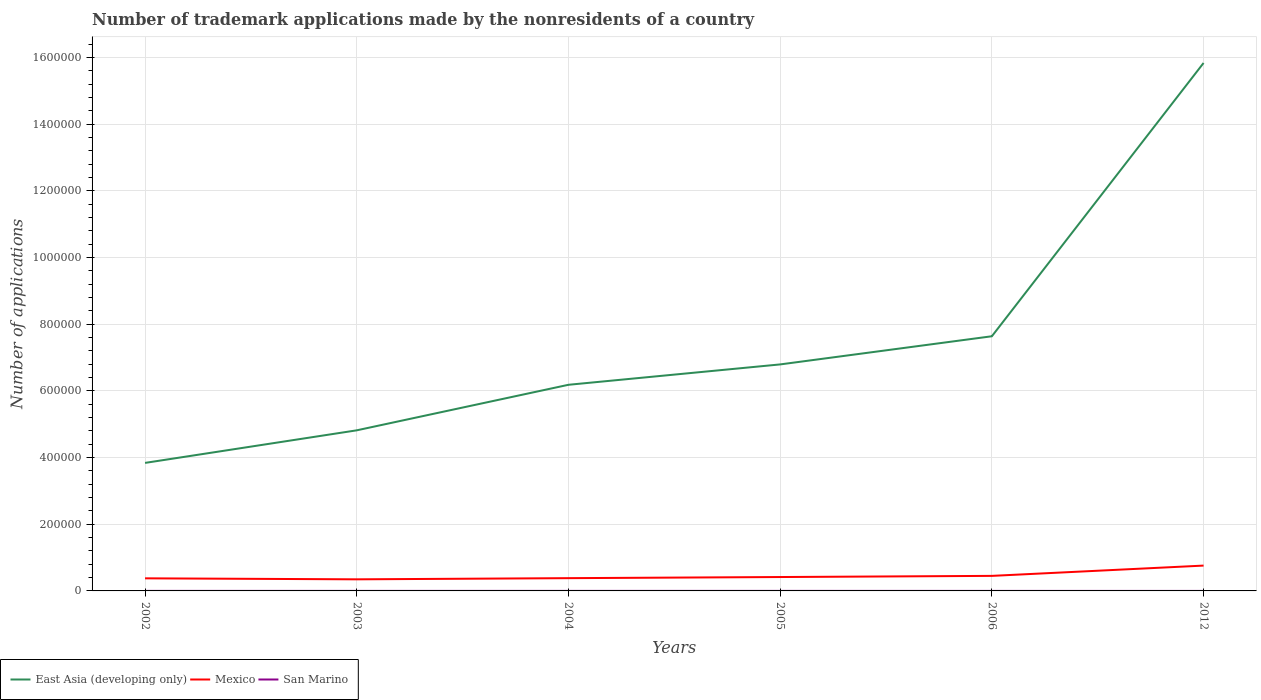How many different coloured lines are there?
Ensure brevity in your answer.  3. Does the line corresponding to East Asia (developing only) intersect with the line corresponding to Mexico?
Give a very brief answer. No. Is the number of lines equal to the number of legend labels?
Your answer should be compact. Yes. Across all years, what is the maximum number of trademark applications made by the nonresidents in Mexico?
Your response must be concise. 3.48e+04. What is the total number of trademark applications made by the nonresidents in Mexico in the graph?
Offer a very short reply. -550. What is the difference between the highest and the second highest number of trademark applications made by the nonresidents in East Asia (developing only)?
Your answer should be very brief. 1.20e+06. How many years are there in the graph?
Provide a succinct answer. 6. What is the difference between two consecutive major ticks on the Y-axis?
Ensure brevity in your answer.  2.00e+05. Where does the legend appear in the graph?
Offer a very short reply. Bottom left. How many legend labels are there?
Give a very brief answer. 3. How are the legend labels stacked?
Your answer should be very brief. Horizontal. What is the title of the graph?
Make the answer very short. Number of trademark applications made by the nonresidents of a country. Does "Armenia" appear as one of the legend labels in the graph?
Offer a terse response. No. What is the label or title of the Y-axis?
Your answer should be very brief. Number of applications. What is the Number of applications in East Asia (developing only) in 2002?
Make the answer very short. 3.84e+05. What is the Number of applications in Mexico in 2002?
Your response must be concise. 3.78e+04. What is the Number of applications in San Marino in 2002?
Offer a very short reply. 79. What is the Number of applications of East Asia (developing only) in 2003?
Your answer should be very brief. 4.82e+05. What is the Number of applications of Mexico in 2003?
Provide a succinct answer. 3.48e+04. What is the Number of applications in San Marino in 2003?
Your response must be concise. 103. What is the Number of applications of East Asia (developing only) in 2004?
Provide a succinct answer. 6.18e+05. What is the Number of applications of Mexico in 2004?
Provide a succinct answer. 3.83e+04. What is the Number of applications of San Marino in 2004?
Provide a short and direct response. 81. What is the Number of applications of East Asia (developing only) in 2005?
Give a very brief answer. 6.80e+05. What is the Number of applications in Mexico in 2005?
Ensure brevity in your answer.  4.17e+04. What is the Number of applications of East Asia (developing only) in 2006?
Keep it short and to the point. 7.64e+05. What is the Number of applications in Mexico in 2006?
Your response must be concise. 4.52e+04. What is the Number of applications of San Marino in 2006?
Provide a short and direct response. 63. What is the Number of applications in East Asia (developing only) in 2012?
Your answer should be compact. 1.58e+06. What is the Number of applications in Mexico in 2012?
Give a very brief answer. 7.60e+04. What is the Number of applications of San Marino in 2012?
Provide a succinct answer. 1. Across all years, what is the maximum Number of applications in East Asia (developing only)?
Keep it short and to the point. 1.58e+06. Across all years, what is the maximum Number of applications in Mexico?
Keep it short and to the point. 7.60e+04. Across all years, what is the maximum Number of applications in San Marino?
Provide a succinct answer. 103. Across all years, what is the minimum Number of applications of East Asia (developing only)?
Keep it short and to the point. 3.84e+05. Across all years, what is the minimum Number of applications in Mexico?
Ensure brevity in your answer.  3.48e+04. What is the total Number of applications of East Asia (developing only) in the graph?
Provide a succinct answer. 4.51e+06. What is the total Number of applications of Mexico in the graph?
Make the answer very short. 2.74e+05. What is the total Number of applications in San Marino in the graph?
Offer a very short reply. 422. What is the difference between the Number of applications in East Asia (developing only) in 2002 and that in 2003?
Provide a succinct answer. -9.77e+04. What is the difference between the Number of applications of Mexico in 2002 and that in 2003?
Ensure brevity in your answer.  3001. What is the difference between the Number of applications in San Marino in 2002 and that in 2003?
Offer a terse response. -24. What is the difference between the Number of applications in East Asia (developing only) in 2002 and that in 2004?
Provide a succinct answer. -2.34e+05. What is the difference between the Number of applications in Mexico in 2002 and that in 2004?
Provide a succinct answer. -550. What is the difference between the Number of applications of East Asia (developing only) in 2002 and that in 2005?
Provide a succinct answer. -2.95e+05. What is the difference between the Number of applications of Mexico in 2002 and that in 2005?
Give a very brief answer. -3916. What is the difference between the Number of applications in San Marino in 2002 and that in 2005?
Provide a short and direct response. -16. What is the difference between the Number of applications in East Asia (developing only) in 2002 and that in 2006?
Offer a terse response. -3.80e+05. What is the difference between the Number of applications in Mexico in 2002 and that in 2006?
Give a very brief answer. -7397. What is the difference between the Number of applications in East Asia (developing only) in 2002 and that in 2012?
Your response must be concise. -1.20e+06. What is the difference between the Number of applications of Mexico in 2002 and that in 2012?
Offer a terse response. -3.82e+04. What is the difference between the Number of applications in San Marino in 2002 and that in 2012?
Provide a short and direct response. 78. What is the difference between the Number of applications in East Asia (developing only) in 2003 and that in 2004?
Offer a terse response. -1.37e+05. What is the difference between the Number of applications in Mexico in 2003 and that in 2004?
Ensure brevity in your answer.  -3551. What is the difference between the Number of applications of East Asia (developing only) in 2003 and that in 2005?
Ensure brevity in your answer.  -1.98e+05. What is the difference between the Number of applications in Mexico in 2003 and that in 2005?
Offer a terse response. -6917. What is the difference between the Number of applications of San Marino in 2003 and that in 2005?
Your answer should be compact. 8. What is the difference between the Number of applications of East Asia (developing only) in 2003 and that in 2006?
Ensure brevity in your answer.  -2.82e+05. What is the difference between the Number of applications in Mexico in 2003 and that in 2006?
Ensure brevity in your answer.  -1.04e+04. What is the difference between the Number of applications of East Asia (developing only) in 2003 and that in 2012?
Give a very brief answer. -1.10e+06. What is the difference between the Number of applications in Mexico in 2003 and that in 2012?
Provide a short and direct response. -4.12e+04. What is the difference between the Number of applications in San Marino in 2003 and that in 2012?
Your answer should be very brief. 102. What is the difference between the Number of applications of East Asia (developing only) in 2004 and that in 2005?
Make the answer very short. -6.11e+04. What is the difference between the Number of applications in Mexico in 2004 and that in 2005?
Offer a terse response. -3366. What is the difference between the Number of applications of East Asia (developing only) in 2004 and that in 2006?
Give a very brief answer. -1.46e+05. What is the difference between the Number of applications of Mexico in 2004 and that in 2006?
Give a very brief answer. -6847. What is the difference between the Number of applications in San Marino in 2004 and that in 2006?
Ensure brevity in your answer.  18. What is the difference between the Number of applications of East Asia (developing only) in 2004 and that in 2012?
Your answer should be very brief. -9.66e+05. What is the difference between the Number of applications in Mexico in 2004 and that in 2012?
Offer a terse response. -3.77e+04. What is the difference between the Number of applications in East Asia (developing only) in 2005 and that in 2006?
Offer a terse response. -8.45e+04. What is the difference between the Number of applications in Mexico in 2005 and that in 2006?
Give a very brief answer. -3481. What is the difference between the Number of applications of San Marino in 2005 and that in 2006?
Offer a very short reply. 32. What is the difference between the Number of applications in East Asia (developing only) in 2005 and that in 2012?
Give a very brief answer. -9.04e+05. What is the difference between the Number of applications in Mexico in 2005 and that in 2012?
Provide a succinct answer. -3.43e+04. What is the difference between the Number of applications of San Marino in 2005 and that in 2012?
Ensure brevity in your answer.  94. What is the difference between the Number of applications in East Asia (developing only) in 2006 and that in 2012?
Make the answer very short. -8.20e+05. What is the difference between the Number of applications in Mexico in 2006 and that in 2012?
Keep it short and to the point. -3.08e+04. What is the difference between the Number of applications in East Asia (developing only) in 2002 and the Number of applications in Mexico in 2003?
Ensure brevity in your answer.  3.49e+05. What is the difference between the Number of applications of East Asia (developing only) in 2002 and the Number of applications of San Marino in 2003?
Your answer should be very brief. 3.84e+05. What is the difference between the Number of applications of Mexico in 2002 and the Number of applications of San Marino in 2003?
Provide a short and direct response. 3.77e+04. What is the difference between the Number of applications in East Asia (developing only) in 2002 and the Number of applications in Mexico in 2004?
Ensure brevity in your answer.  3.46e+05. What is the difference between the Number of applications in East Asia (developing only) in 2002 and the Number of applications in San Marino in 2004?
Provide a succinct answer. 3.84e+05. What is the difference between the Number of applications in Mexico in 2002 and the Number of applications in San Marino in 2004?
Offer a terse response. 3.77e+04. What is the difference between the Number of applications of East Asia (developing only) in 2002 and the Number of applications of Mexico in 2005?
Keep it short and to the point. 3.42e+05. What is the difference between the Number of applications of East Asia (developing only) in 2002 and the Number of applications of San Marino in 2005?
Your answer should be compact. 3.84e+05. What is the difference between the Number of applications of Mexico in 2002 and the Number of applications of San Marino in 2005?
Provide a succinct answer. 3.77e+04. What is the difference between the Number of applications of East Asia (developing only) in 2002 and the Number of applications of Mexico in 2006?
Give a very brief answer. 3.39e+05. What is the difference between the Number of applications in East Asia (developing only) in 2002 and the Number of applications in San Marino in 2006?
Your answer should be compact. 3.84e+05. What is the difference between the Number of applications in Mexico in 2002 and the Number of applications in San Marino in 2006?
Provide a short and direct response. 3.77e+04. What is the difference between the Number of applications of East Asia (developing only) in 2002 and the Number of applications of Mexico in 2012?
Offer a very short reply. 3.08e+05. What is the difference between the Number of applications of East Asia (developing only) in 2002 and the Number of applications of San Marino in 2012?
Provide a succinct answer. 3.84e+05. What is the difference between the Number of applications in Mexico in 2002 and the Number of applications in San Marino in 2012?
Offer a terse response. 3.78e+04. What is the difference between the Number of applications in East Asia (developing only) in 2003 and the Number of applications in Mexico in 2004?
Keep it short and to the point. 4.44e+05. What is the difference between the Number of applications of East Asia (developing only) in 2003 and the Number of applications of San Marino in 2004?
Offer a very short reply. 4.82e+05. What is the difference between the Number of applications in Mexico in 2003 and the Number of applications in San Marino in 2004?
Your response must be concise. 3.47e+04. What is the difference between the Number of applications in East Asia (developing only) in 2003 and the Number of applications in Mexico in 2005?
Provide a succinct answer. 4.40e+05. What is the difference between the Number of applications in East Asia (developing only) in 2003 and the Number of applications in San Marino in 2005?
Provide a succinct answer. 4.82e+05. What is the difference between the Number of applications of Mexico in 2003 and the Number of applications of San Marino in 2005?
Your answer should be compact. 3.47e+04. What is the difference between the Number of applications in East Asia (developing only) in 2003 and the Number of applications in Mexico in 2006?
Keep it short and to the point. 4.37e+05. What is the difference between the Number of applications of East Asia (developing only) in 2003 and the Number of applications of San Marino in 2006?
Your response must be concise. 4.82e+05. What is the difference between the Number of applications in Mexico in 2003 and the Number of applications in San Marino in 2006?
Your answer should be very brief. 3.47e+04. What is the difference between the Number of applications of East Asia (developing only) in 2003 and the Number of applications of Mexico in 2012?
Provide a succinct answer. 4.06e+05. What is the difference between the Number of applications in East Asia (developing only) in 2003 and the Number of applications in San Marino in 2012?
Your answer should be compact. 4.82e+05. What is the difference between the Number of applications in Mexico in 2003 and the Number of applications in San Marino in 2012?
Keep it short and to the point. 3.48e+04. What is the difference between the Number of applications of East Asia (developing only) in 2004 and the Number of applications of Mexico in 2005?
Provide a short and direct response. 5.77e+05. What is the difference between the Number of applications of East Asia (developing only) in 2004 and the Number of applications of San Marino in 2005?
Your answer should be compact. 6.18e+05. What is the difference between the Number of applications in Mexico in 2004 and the Number of applications in San Marino in 2005?
Keep it short and to the point. 3.82e+04. What is the difference between the Number of applications of East Asia (developing only) in 2004 and the Number of applications of Mexico in 2006?
Make the answer very short. 5.73e+05. What is the difference between the Number of applications of East Asia (developing only) in 2004 and the Number of applications of San Marino in 2006?
Ensure brevity in your answer.  6.18e+05. What is the difference between the Number of applications in Mexico in 2004 and the Number of applications in San Marino in 2006?
Provide a short and direct response. 3.83e+04. What is the difference between the Number of applications in East Asia (developing only) in 2004 and the Number of applications in Mexico in 2012?
Your answer should be compact. 5.42e+05. What is the difference between the Number of applications of East Asia (developing only) in 2004 and the Number of applications of San Marino in 2012?
Keep it short and to the point. 6.18e+05. What is the difference between the Number of applications of Mexico in 2004 and the Number of applications of San Marino in 2012?
Provide a succinct answer. 3.83e+04. What is the difference between the Number of applications of East Asia (developing only) in 2005 and the Number of applications of Mexico in 2006?
Your response must be concise. 6.34e+05. What is the difference between the Number of applications of East Asia (developing only) in 2005 and the Number of applications of San Marino in 2006?
Make the answer very short. 6.80e+05. What is the difference between the Number of applications in Mexico in 2005 and the Number of applications in San Marino in 2006?
Ensure brevity in your answer.  4.16e+04. What is the difference between the Number of applications in East Asia (developing only) in 2005 and the Number of applications in Mexico in 2012?
Ensure brevity in your answer.  6.04e+05. What is the difference between the Number of applications in East Asia (developing only) in 2005 and the Number of applications in San Marino in 2012?
Provide a succinct answer. 6.80e+05. What is the difference between the Number of applications in Mexico in 2005 and the Number of applications in San Marino in 2012?
Provide a short and direct response. 4.17e+04. What is the difference between the Number of applications of East Asia (developing only) in 2006 and the Number of applications of Mexico in 2012?
Offer a terse response. 6.88e+05. What is the difference between the Number of applications in East Asia (developing only) in 2006 and the Number of applications in San Marino in 2012?
Your answer should be very brief. 7.64e+05. What is the difference between the Number of applications in Mexico in 2006 and the Number of applications in San Marino in 2012?
Provide a succinct answer. 4.52e+04. What is the average Number of applications of East Asia (developing only) per year?
Your answer should be compact. 7.52e+05. What is the average Number of applications in Mexico per year?
Offer a terse response. 4.56e+04. What is the average Number of applications of San Marino per year?
Your response must be concise. 70.33. In the year 2002, what is the difference between the Number of applications in East Asia (developing only) and Number of applications in Mexico?
Your answer should be compact. 3.46e+05. In the year 2002, what is the difference between the Number of applications of East Asia (developing only) and Number of applications of San Marino?
Make the answer very short. 3.84e+05. In the year 2002, what is the difference between the Number of applications in Mexico and Number of applications in San Marino?
Your response must be concise. 3.77e+04. In the year 2003, what is the difference between the Number of applications of East Asia (developing only) and Number of applications of Mexico?
Your answer should be very brief. 4.47e+05. In the year 2003, what is the difference between the Number of applications in East Asia (developing only) and Number of applications in San Marino?
Give a very brief answer. 4.82e+05. In the year 2003, what is the difference between the Number of applications of Mexico and Number of applications of San Marino?
Your response must be concise. 3.47e+04. In the year 2004, what is the difference between the Number of applications in East Asia (developing only) and Number of applications in Mexico?
Offer a very short reply. 5.80e+05. In the year 2004, what is the difference between the Number of applications in East Asia (developing only) and Number of applications in San Marino?
Keep it short and to the point. 6.18e+05. In the year 2004, what is the difference between the Number of applications in Mexico and Number of applications in San Marino?
Provide a short and direct response. 3.82e+04. In the year 2005, what is the difference between the Number of applications in East Asia (developing only) and Number of applications in Mexico?
Your answer should be very brief. 6.38e+05. In the year 2005, what is the difference between the Number of applications of East Asia (developing only) and Number of applications of San Marino?
Your answer should be compact. 6.80e+05. In the year 2005, what is the difference between the Number of applications of Mexico and Number of applications of San Marino?
Make the answer very short. 4.16e+04. In the year 2006, what is the difference between the Number of applications in East Asia (developing only) and Number of applications in Mexico?
Your answer should be compact. 7.19e+05. In the year 2006, what is the difference between the Number of applications in East Asia (developing only) and Number of applications in San Marino?
Give a very brief answer. 7.64e+05. In the year 2006, what is the difference between the Number of applications in Mexico and Number of applications in San Marino?
Make the answer very short. 4.51e+04. In the year 2012, what is the difference between the Number of applications of East Asia (developing only) and Number of applications of Mexico?
Make the answer very short. 1.51e+06. In the year 2012, what is the difference between the Number of applications of East Asia (developing only) and Number of applications of San Marino?
Your answer should be compact. 1.58e+06. In the year 2012, what is the difference between the Number of applications of Mexico and Number of applications of San Marino?
Your answer should be compact. 7.60e+04. What is the ratio of the Number of applications of East Asia (developing only) in 2002 to that in 2003?
Your answer should be compact. 0.8. What is the ratio of the Number of applications in Mexico in 2002 to that in 2003?
Your answer should be very brief. 1.09. What is the ratio of the Number of applications in San Marino in 2002 to that in 2003?
Offer a very short reply. 0.77. What is the ratio of the Number of applications in East Asia (developing only) in 2002 to that in 2004?
Your response must be concise. 0.62. What is the ratio of the Number of applications in Mexico in 2002 to that in 2004?
Ensure brevity in your answer.  0.99. What is the ratio of the Number of applications of San Marino in 2002 to that in 2004?
Your answer should be very brief. 0.98. What is the ratio of the Number of applications in East Asia (developing only) in 2002 to that in 2005?
Provide a short and direct response. 0.57. What is the ratio of the Number of applications of Mexico in 2002 to that in 2005?
Provide a short and direct response. 0.91. What is the ratio of the Number of applications of San Marino in 2002 to that in 2005?
Keep it short and to the point. 0.83. What is the ratio of the Number of applications of East Asia (developing only) in 2002 to that in 2006?
Ensure brevity in your answer.  0.5. What is the ratio of the Number of applications in Mexico in 2002 to that in 2006?
Provide a succinct answer. 0.84. What is the ratio of the Number of applications of San Marino in 2002 to that in 2006?
Give a very brief answer. 1.25. What is the ratio of the Number of applications of East Asia (developing only) in 2002 to that in 2012?
Your answer should be very brief. 0.24. What is the ratio of the Number of applications in Mexico in 2002 to that in 2012?
Give a very brief answer. 0.5. What is the ratio of the Number of applications of San Marino in 2002 to that in 2012?
Provide a short and direct response. 79. What is the ratio of the Number of applications in East Asia (developing only) in 2003 to that in 2004?
Offer a terse response. 0.78. What is the ratio of the Number of applications of Mexico in 2003 to that in 2004?
Make the answer very short. 0.91. What is the ratio of the Number of applications in San Marino in 2003 to that in 2004?
Provide a succinct answer. 1.27. What is the ratio of the Number of applications in East Asia (developing only) in 2003 to that in 2005?
Keep it short and to the point. 0.71. What is the ratio of the Number of applications of Mexico in 2003 to that in 2005?
Offer a terse response. 0.83. What is the ratio of the Number of applications in San Marino in 2003 to that in 2005?
Make the answer very short. 1.08. What is the ratio of the Number of applications in East Asia (developing only) in 2003 to that in 2006?
Offer a terse response. 0.63. What is the ratio of the Number of applications of Mexico in 2003 to that in 2006?
Keep it short and to the point. 0.77. What is the ratio of the Number of applications in San Marino in 2003 to that in 2006?
Give a very brief answer. 1.63. What is the ratio of the Number of applications in East Asia (developing only) in 2003 to that in 2012?
Your answer should be compact. 0.3. What is the ratio of the Number of applications in Mexico in 2003 to that in 2012?
Keep it short and to the point. 0.46. What is the ratio of the Number of applications in San Marino in 2003 to that in 2012?
Give a very brief answer. 103. What is the ratio of the Number of applications in East Asia (developing only) in 2004 to that in 2005?
Provide a succinct answer. 0.91. What is the ratio of the Number of applications in Mexico in 2004 to that in 2005?
Offer a terse response. 0.92. What is the ratio of the Number of applications in San Marino in 2004 to that in 2005?
Provide a short and direct response. 0.85. What is the ratio of the Number of applications of East Asia (developing only) in 2004 to that in 2006?
Give a very brief answer. 0.81. What is the ratio of the Number of applications of Mexico in 2004 to that in 2006?
Make the answer very short. 0.85. What is the ratio of the Number of applications in San Marino in 2004 to that in 2006?
Your answer should be very brief. 1.29. What is the ratio of the Number of applications in East Asia (developing only) in 2004 to that in 2012?
Provide a short and direct response. 0.39. What is the ratio of the Number of applications in Mexico in 2004 to that in 2012?
Ensure brevity in your answer.  0.5. What is the ratio of the Number of applications in East Asia (developing only) in 2005 to that in 2006?
Make the answer very short. 0.89. What is the ratio of the Number of applications of Mexico in 2005 to that in 2006?
Make the answer very short. 0.92. What is the ratio of the Number of applications in San Marino in 2005 to that in 2006?
Offer a very short reply. 1.51. What is the ratio of the Number of applications in East Asia (developing only) in 2005 to that in 2012?
Offer a very short reply. 0.43. What is the ratio of the Number of applications in Mexico in 2005 to that in 2012?
Your answer should be compact. 0.55. What is the ratio of the Number of applications in San Marino in 2005 to that in 2012?
Make the answer very short. 95. What is the ratio of the Number of applications of East Asia (developing only) in 2006 to that in 2012?
Your answer should be very brief. 0.48. What is the ratio of the Number of applications of Mexico in 2006 to that in 2012?
Provide a succinct answer. 0.59. What is the difference between the highest and the second highest Number of applications in East Asia (developing only)?
Make the answer very short. 8.20e+05. What is the difference between the highest and the second highest Number of applications of Mexico?
Provide a short and direct response. 3.08e+04. What is the difference between the highest and the lowest Number of applications in East Asia (developing only)?
Give a very brief answer. 1.20e+06. What is the difference between the highest and the lowest Number of applications in Mexico?
Provide a succinct answer. 4.12e+04. What is the difference between the highest and the lowest Number of applications in San Marino?
Keep it short and to the point. 102. 